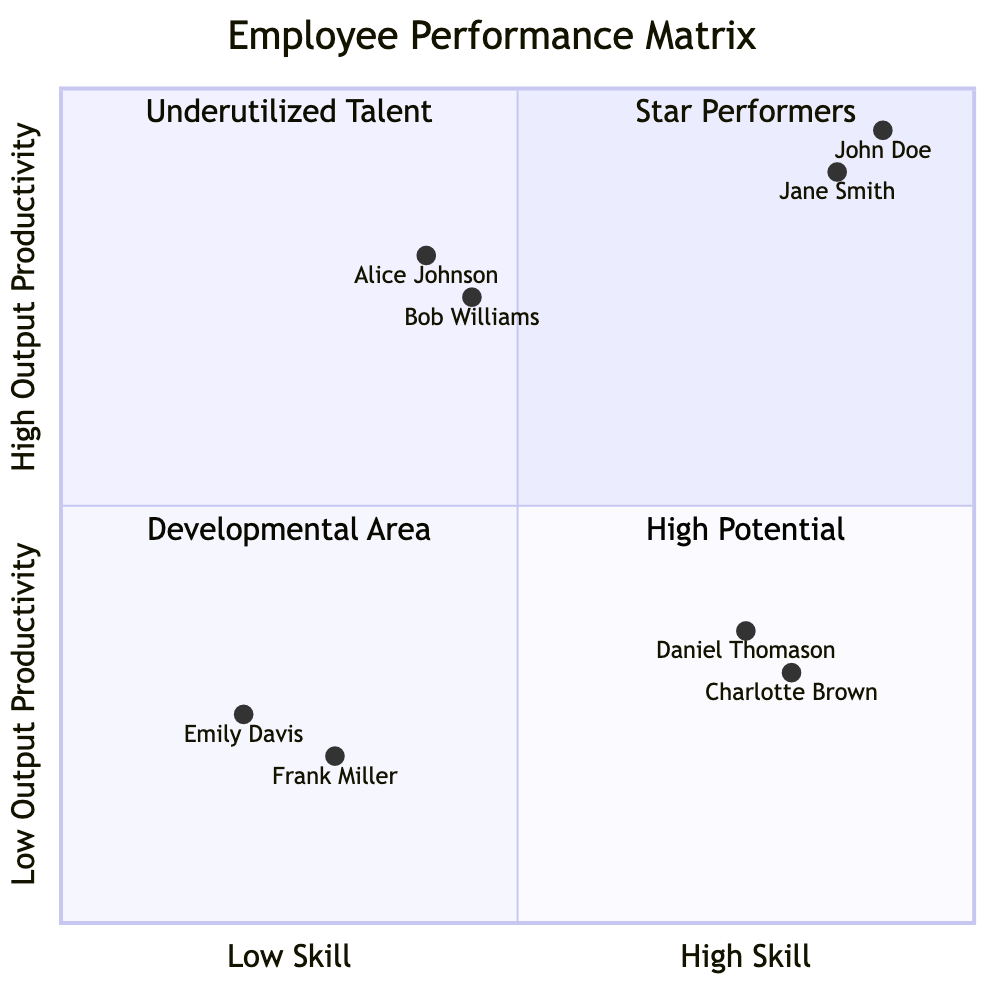What is the label for the quadrant representing employees with high skill and high output productivity? In the quadrant chart, the upper right quadrant is labeled "Star Performers," represent employees who have high skill levels and consistently generate high output productivity.
Answer: Star Performers How many employees are categorized as "High Potential"? The quadrant labeled "High Potential" in the diagram contains a total of two employees, Alice Johnson and Bob Williams, who both show lower skill but high productivity.
Answer: 2 Which employee is in the "Underutilized Talent" quadrant? The "Underutilized Talent" quadrant houses employees Charlotte Brown and Daniel Thomason. Both are highly skilled but exhibiting low productivity.
Answer: Charlotte Brown What achievement is associated with John Doe? In the diagram, John Doe is noted for having reduced assembly time by 20% and for innovating a new robotics technique, showcasing his high output productivity in the "Star Performers" quadrant.
Answer: Reduced assembly time by 20% Which quadrant contains employees with both low skill and low output productivity? The bottom left quadrant of the chart, labeled "Developmental Area," is where employees with low skill levels and low productivity are located, including Emily Davis and Frank Miller.
Answer: Developmental Area What is the common challenge for employees in the "Underutilized Talent" category? Both employees in the "Underutilized Talent" quadrant, Charlotte Brown and Daniel Thomason, face challenges related to project delays and changes in project scope, which limit their productivity.
Answer: Project delays Which employee demonstrates the highest output productivity among those with low skill? In the "High Potential" quadrant, Alice Johnson demonstrates the highest output productivity, completing tasks 10% faster than the average, despite her lower skill level.
Answer: Alice Johnson What is the main challenge faced by Emily Davis? The employee, Emily Davis, faces challenges related to lacking practical experience and requiring extensive training, which impacts her performance in the "Developmental Area."
Answer: Lacks practical experience How many employees are classified as "Star Performers"? Within the "Star Performers" quadrant, there are two employees, John Doe and Jane Smith, both showing high skills and high productivity.
Answer: 2 